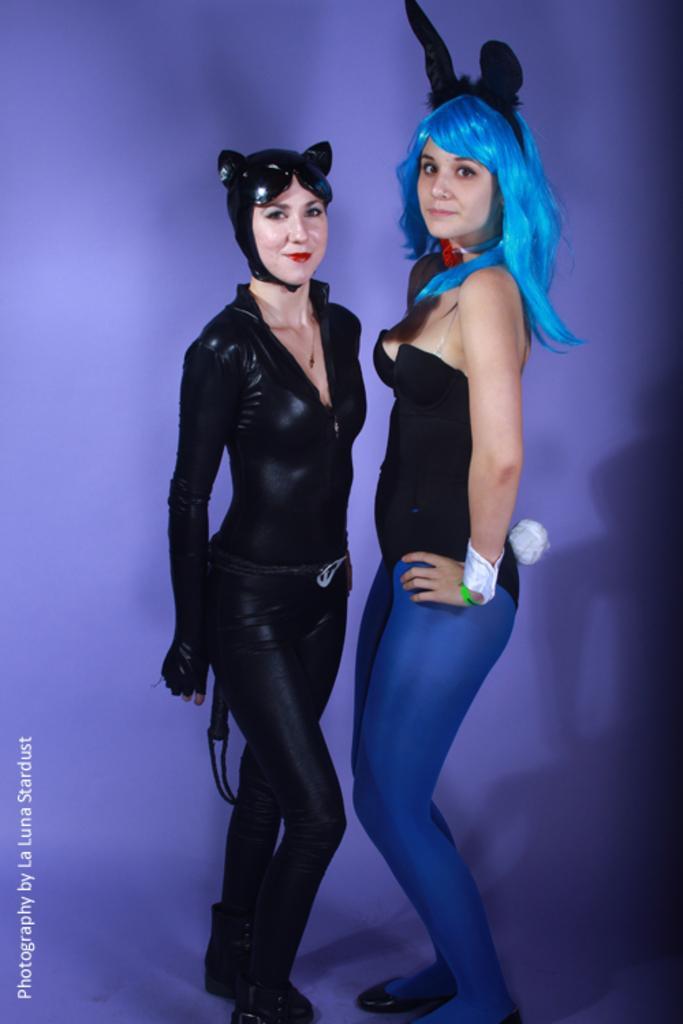Please provide a concise description of this image. In the center of the image we can see two ladies standing. They are wearing costumes. 